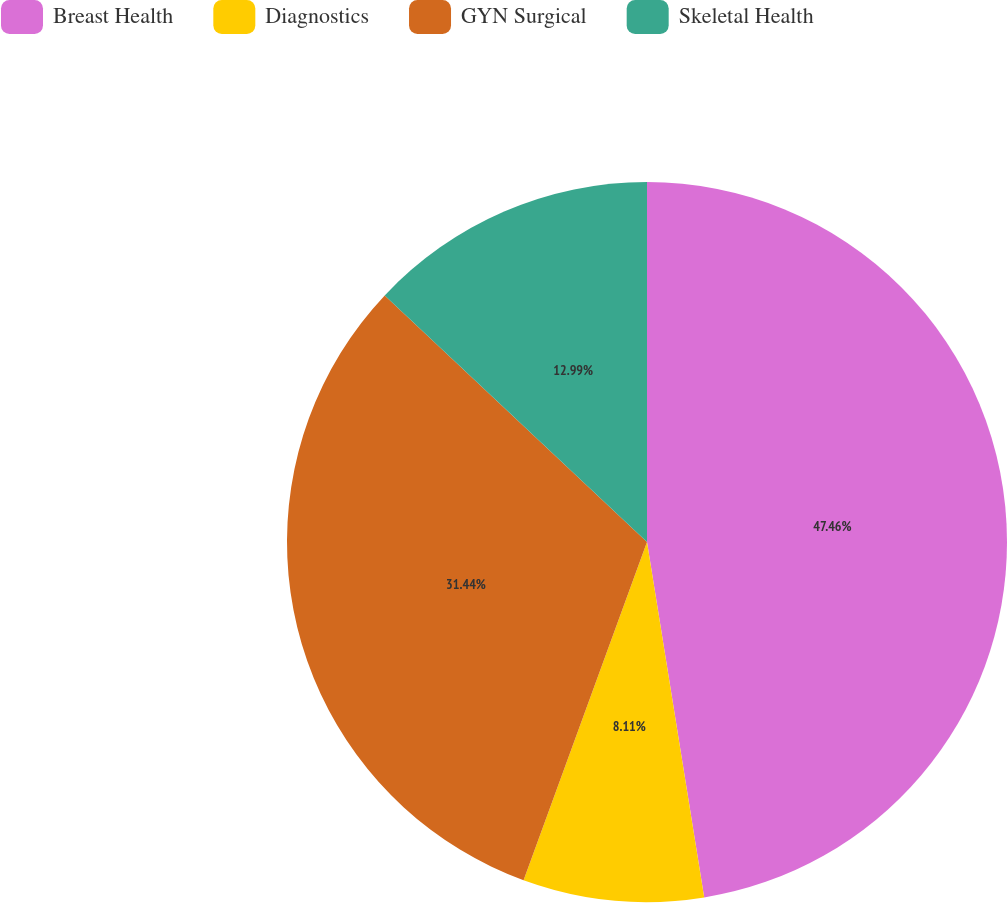<chart> <loc_0><loc_0><loc_500><loc_500><pie_chart><fcel>Breast Health<fcel>Diagnostics<fcel>GYN Surgical<fcel>Skeletal Health<nl><fcel>47.46%<fcel>8.11%<fcel>31.44%<fcel>12.99%<nl></chart> 